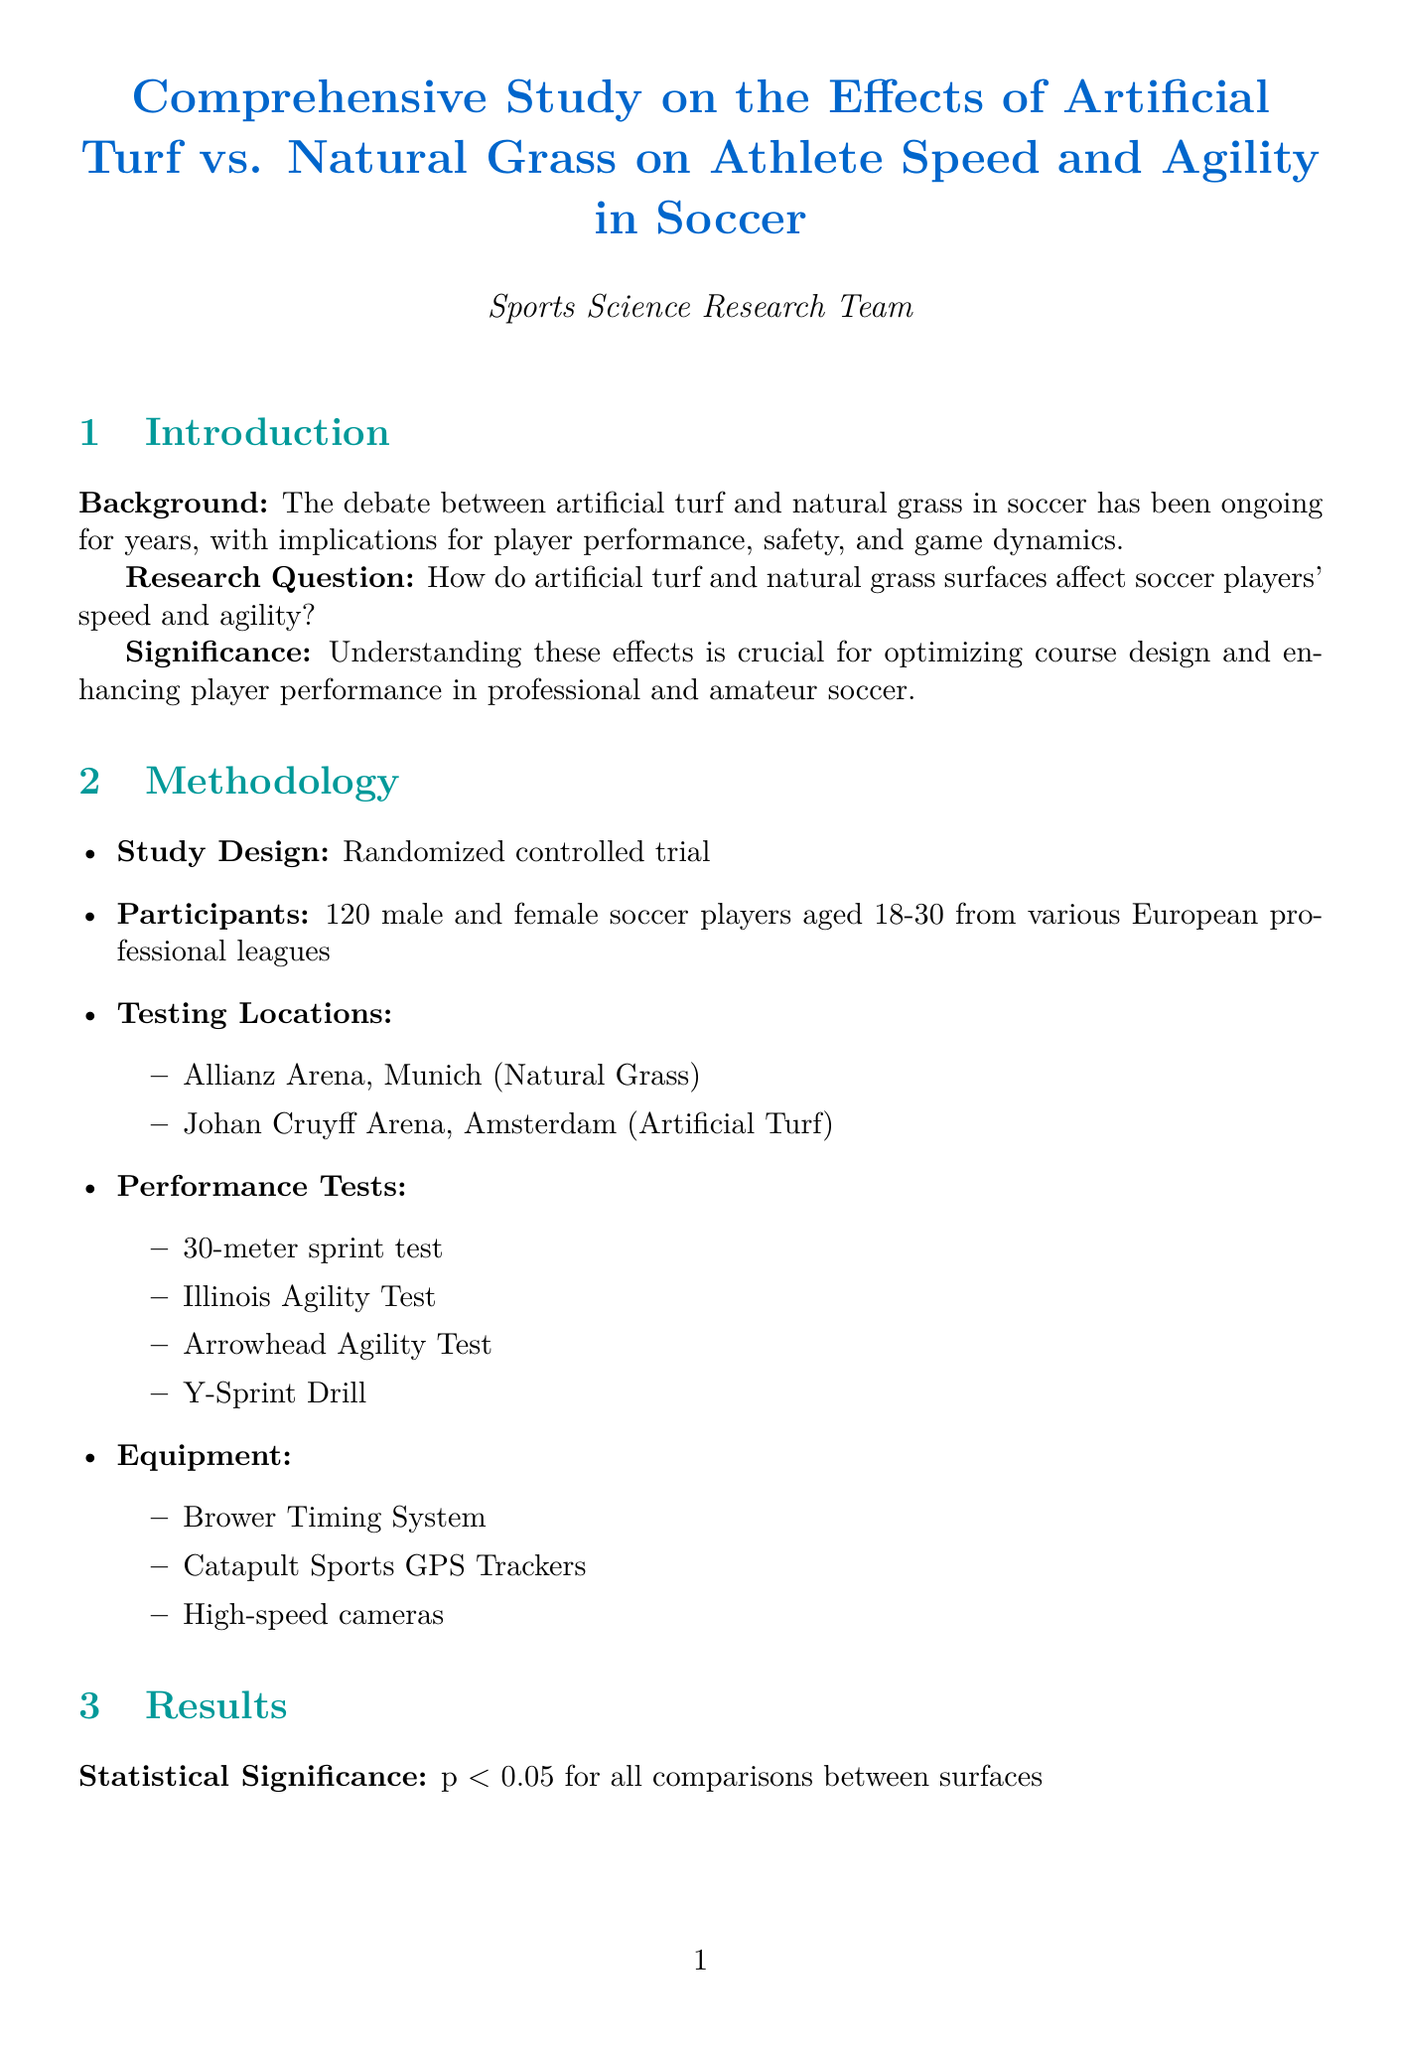What was the average time for the 30-meter sprint test on artificial turf? The average time for the 30-meter sprint test on artificial turf is listed as 4.12 seconds in the results section.
Answer: 4.12 seconds What types of agility tests were conducted? The performance tests include Illinois Agility Test, Arrowhead Agility Test, and Y-Sprint Drill, detailed in the methodology section.
Answer: Illinois Agility Test, Arrowhead Agility Test, Y-Sprint Drill How many participants were in the study? The number of participants is explicitly mentioned as 120 in the methodology section.
Answer: 120 What was the statistical significance level reported for the comparisons? The statistical significance level is provided as p < 0.05 for all comparisons between surfaces in the results section.
Answer: p < 0.05 Which surface showed slightly faster sprint times? The key findings indicate that players demonstrated slightly faster sprint times on artificial turf according to the discussion section.
Answer: Artificial turf What is a limitation mentioned in the study? The discussion section outlines several limitations, including that the study was conducted in controlled environments and may not fully reflect match conditions.
Answer: Controlled environments What does the conclusion recommend for further research? The recommendations in the conclusion suggest further research on long-term effects and injury prevention.
Answer: Long-term effects and injury prevention What were the two testing locations used in this study? The testing locations specified in the methodology are Allianz Arena, Munich (Natural Grass) and Johan Cruyff Arena, Amsterdam (Artificial Turf).
Answer: Allianz Arena, Johan Cruyff Arena What is one key finding regarding player adaptability? The discussion notes that individual player adaptability varied based on experience with each surface, indicating a nuanced understanding of player performance.
Answer: Varied based on experience with each surface 